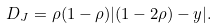<formula> <loc_0><loc_0><loc_500><loc_500>D _ { J } = \rho ( 1 - \rho ) | ( 1 - 2 \rho ) - y | .</formula> 